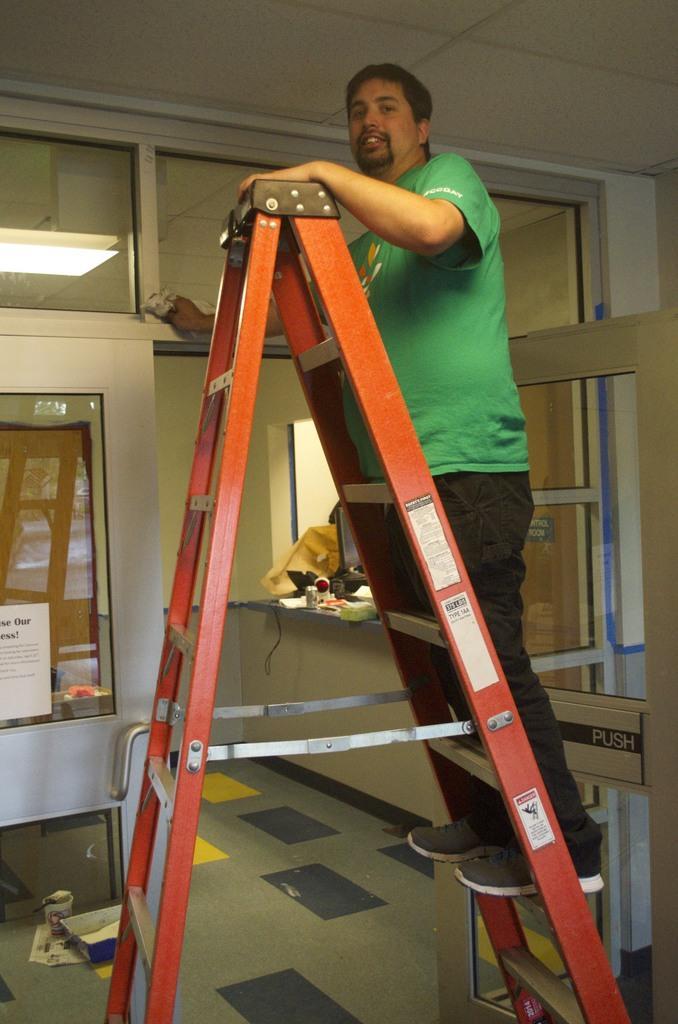How would you summarize this image in a sentence or two? In this image I can see on the right side there is a glass door, in the middle there is a man standing on the ladder, he is wearing the t-shirt, trouser and shoes. On the left side it looks like a light. 